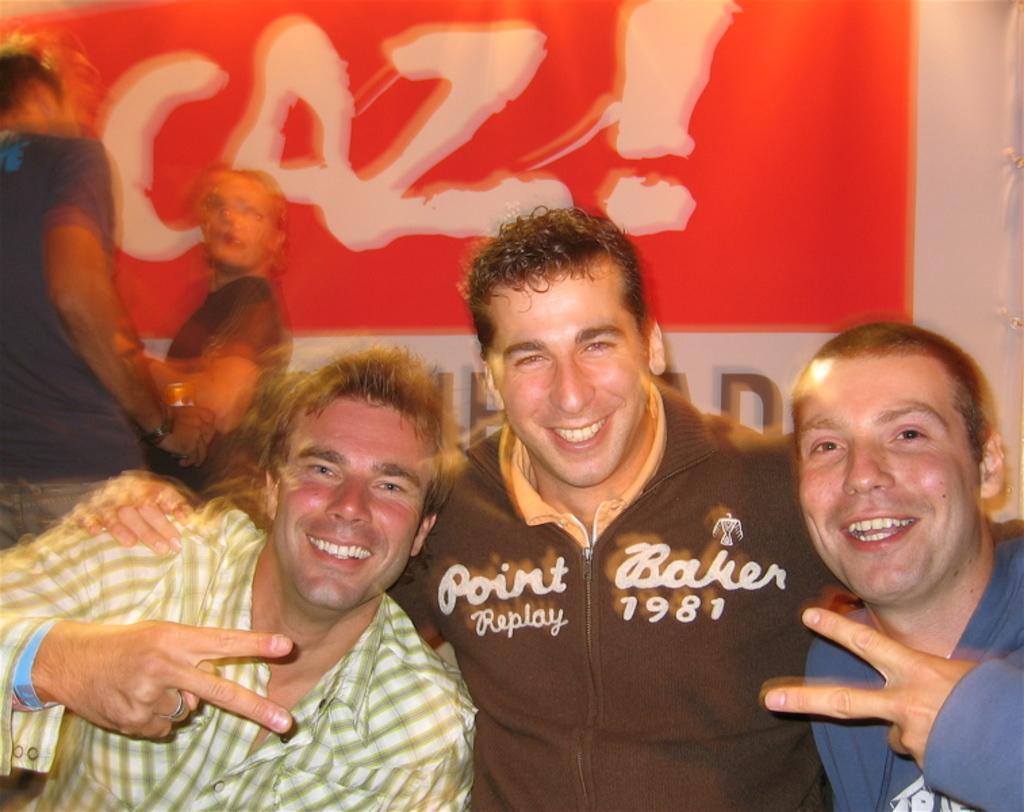In one or two sentences, can you explain what this image depicts? In this image I can see three men smiling and giving pose for the picture. On the left side, I can see two persons. In the background, I can see a board on which I can see some text. 